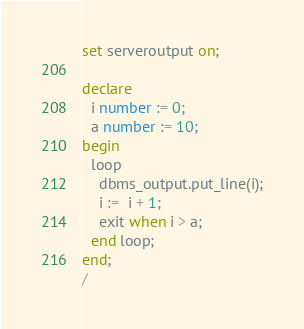Convert code to text. <code><loc_0><loc_0><loc_500><loc_500><_SQL_>set serveroutput on;

declare
  i number := 0;
  a number := 10;
begin
  loop
    dbms_output.put_line(i);
    i :=  i + 1;
    exit when i > a;
  end loop;
end;
/</code> 